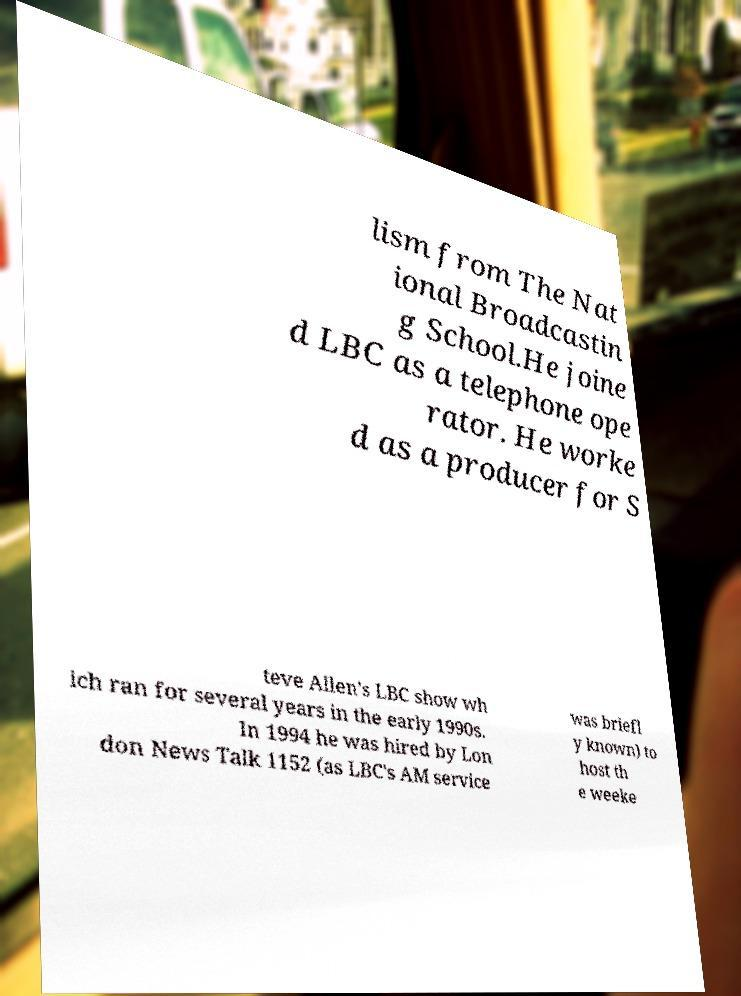Please identify and transcribe the text found in this image. lism from The Nat ional Broadcastin g School.He joine d LBC as a telephone ope rator. He worke d as a producer for S teve Allen's LBC show wh ich ran for several years in the early 1990s. In 1994 he was hired by Lon don News Talk 1152 (as LBC's AM service was briefl y known) to host th e weeke 